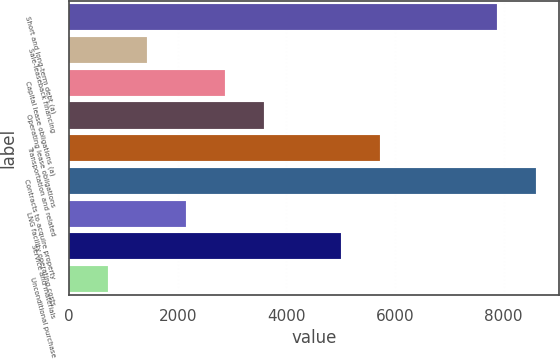Convert chart to OTSL. <chart><loc_0><loc_0><loc_500><loc_500><bar_chart><fcel>Short and long-term debt (a)<fcel>Sale-leaseback financing<fcel>Capital lease obligations (a)<fcel>Operating lease obligations<fcel>Transportation and related<fcel>Contracts to acquire property<fcel>LNG facility operating costs<fcel>Service and materials<fcel>Unconditional purchase<nl><fcel>7880.1<fcel>1435.2<fcel>2867.4<fcel>3583.5<fcel>5731.8<fcel>8596.2<fcel>2151.3<fcel>5015.7<fcel>719.1<nl></chart> 